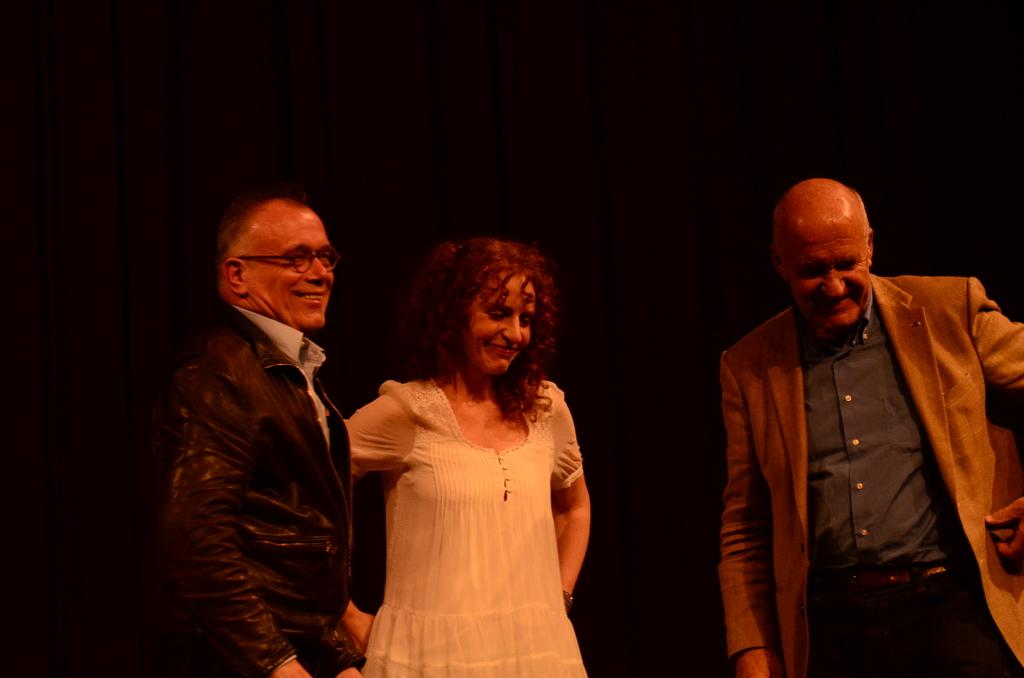How many people are in the image? There are three individuals in the image, two men and a woman. What are the expressions on their faces? All three individuals are smiling in the image. What are the positions of the people in the image? The individuals are standing in the image. What can be observed about the lighting in the image? The background of the image is dark. What type of toy is the woman holding in the image? There is no toy present in the image; the woman is not holding anything. What station do the men work at in the image? There is no indication of a workplace or station in the image; it simply shows the individuals standing and smiling. 